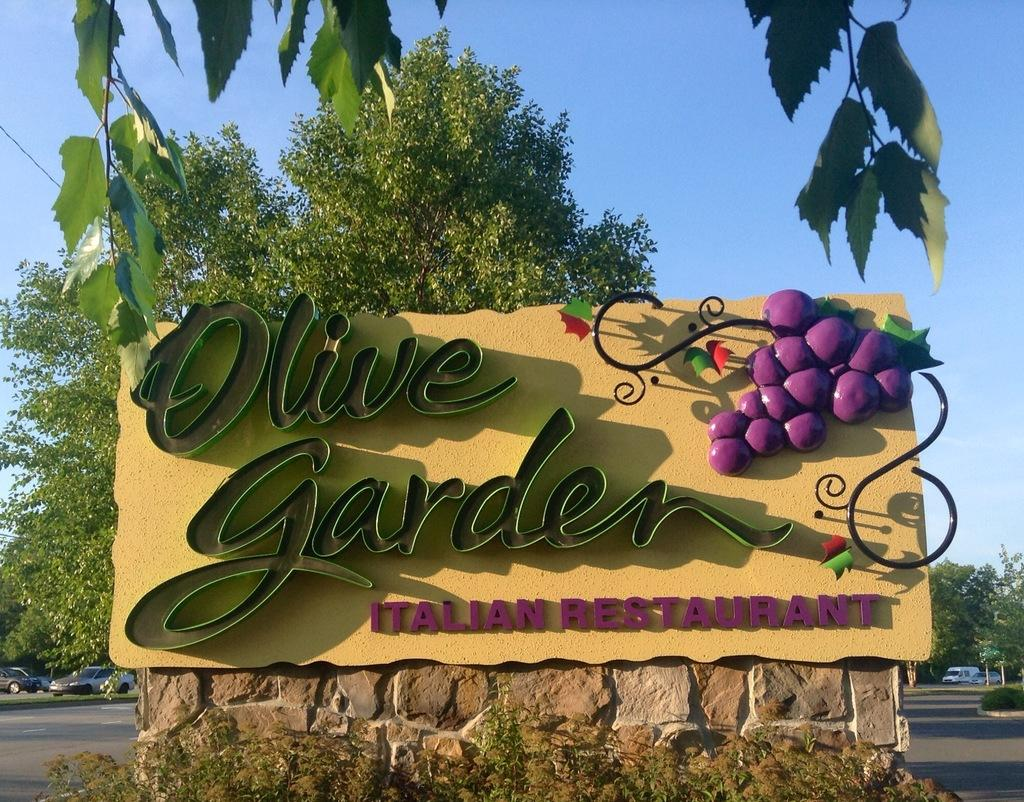What is the board in the image is advertising? The board has "Olive Garden Italian Restaurant" written on it, so it is advertising the restaurant. What can be seen in the background of the image? There are trees and vehicles in the background of the image. What type of badge is the guitar wearing in the image? There is no guitar or badge present in the image. How many rolls are visible on the board in the image? The board in the image does not have any rolls; it has the name of a restaurant written on it. 